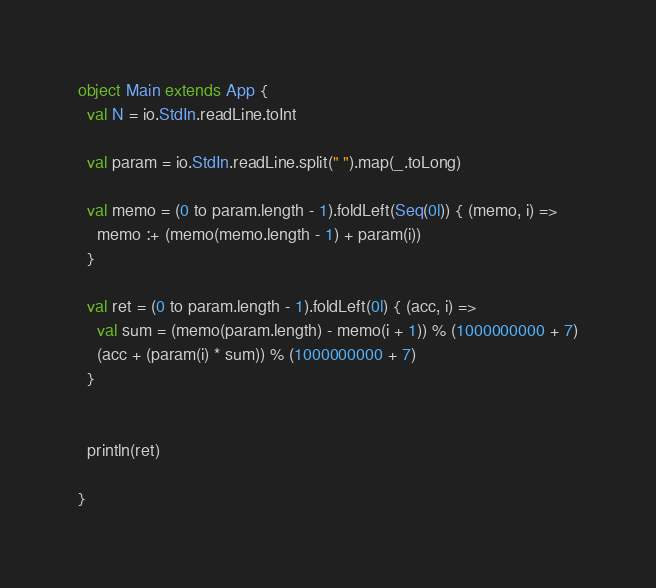Convert code to text. <code><loc_0><loc_0><loc_500><loc_500><_Scala_>object Main extends App {
  val N = io.StdIn.readLine.toInt

  val param = io.StdIn.readLine.split(" ").map(_.toLong)

  val memo = (0 to param.length - 1).foldLeft(Seq(0l)) { (memo, i) => 
    memo :+ (memo(memo.length - 1) + param(i))
  }

  val ret = (0 to param.length - 1).foldLeft(0l) { (acc, i) =>
    val sum = (memo(param.length) - memo(i + 1)) % (1000000000 + 7)
    (acc + (param(i) * sum)) % (1000000000 + 7)
  }


  println(ret)

}

</code> 